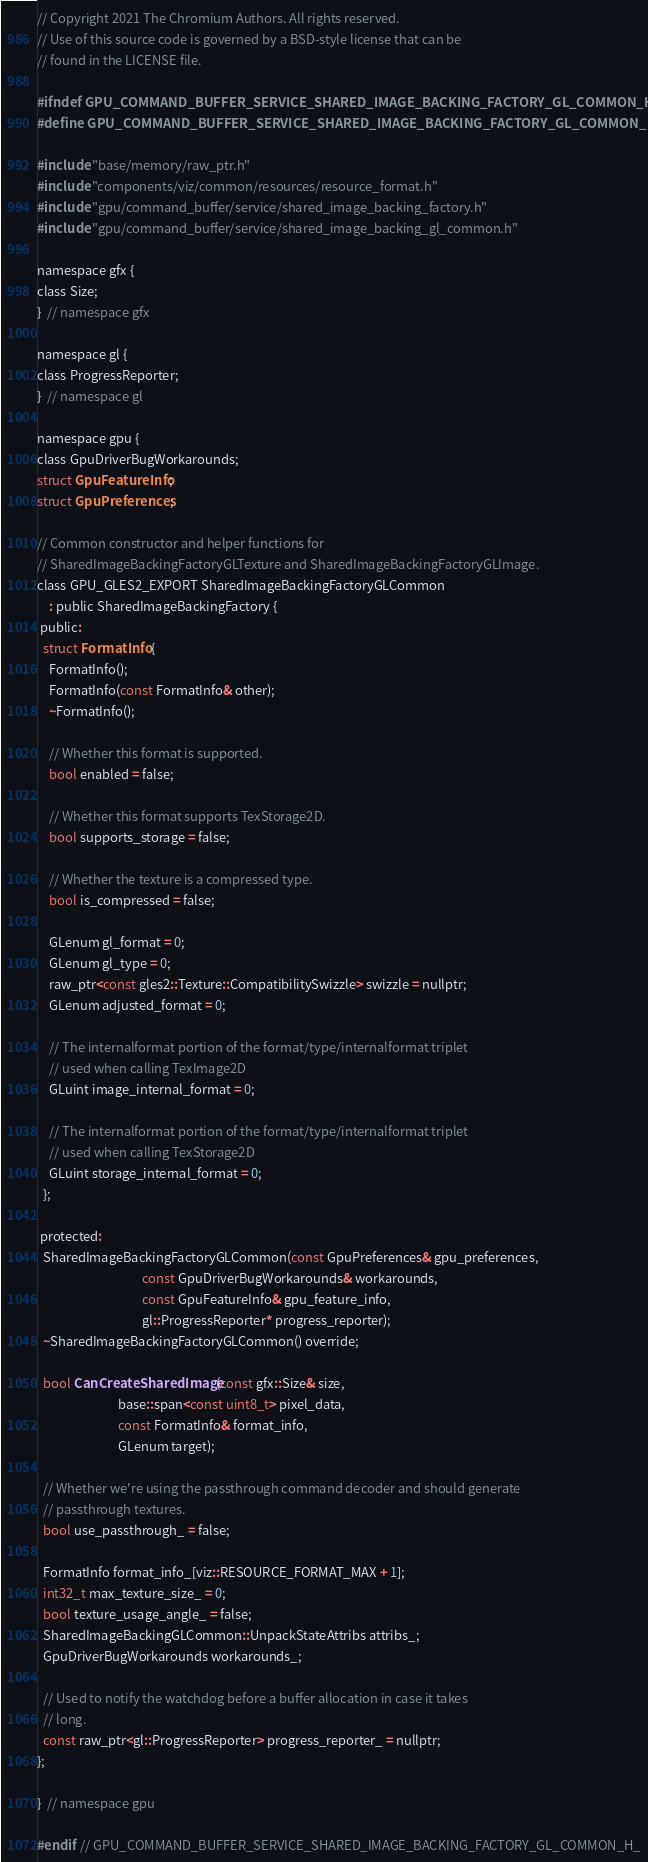<code> <loc_0><loc_0><loc_500><loc_500><_C_>// Copyright 2021 The Chromium Authors. All rights reserved.
// Use of this source code is governed by a BSD-style license that can be
// found in the LICENSE file.

#ifndef GPU_COMMAND_BUFFER_SERVICE_SHARED_IMAGE_BACKING_FACTORY_GL_COMMON_H_
#define GPU_COMMAND_BUFFER_SERVICE_SHARED_IMAGE_BACKING_FACTORY_GL_COMMON_H_

#include "base/memory/raw_ptr.h"
#include "components/viz/common/resources/resource_format.h"
#include "gpu/command_buffer/service/shared_image_backing_factory.h"
#include "gpu/command_buffer/service/shared_image_backing_gl_common.h"

namespace gfx {
class Size;
}  // namespace gfx

namespace gl {
class ProgressReporter;
}  // namespace gl

namespace gpu {
class GpuDriverBugWorkarounds;
struct GpuFeatureInfo;
struct GpuPreferences;

// Common constructor and helper functions for
// SharedImageBackingFactoryGLTexture and SharedImageBackingFactoryGLImage.
class GPU_GLES2_EXPORT SharedImageBackingFactoryGLCommon
    : public SharedImageBackingFactory {
 public:
  struct FormatInfo {
    FormatInfo();
    FormatInfo(const FormatInfo& other);
    ~FormatInfo();

    // Whether this format is supported.
    bool enabled = false;

    // Whether this format supports TexStorage2D.
    bool supports_storage = false;

    // Whether the texture is a compressed type.
    bool is_compressed = false;

    GLenum gl_format = 0;
    GLenum gl_type = 0;
    raw_ptr<const gles2::Texture::CompatibilitySwizzle> swizzle = nullptr;
    GLenum adjusted_format = 0;

    // The internalformat portion of the format/type/internalformat triplet
    // used when calling TexImage2D
    GLuint image_internal_format = 0;

    // The internalformat portion of the format/type/internalformat triplet
    // used when calling TexStorage2D
    GLuint storage_internal_format = 0;
  };

 protected:
  SharedImageBackingFactoryGLCommon(const GpuPreferences& gpu_preferences,
                                    const GpuDriverBugWorkarounds& workarounds,
                                    const GpuFeatureInfo& gpu_feature_info,
                                    gl::ProgressReporter* progress_reporter);
  ~SharedImageBackingFactoryGLCommon() override;

  bool CanCreateSharedImage(const gfx::Size& size,
                            base::span<const uint8_t> pixel_data,
                            const FormatInfo& format_info,
                            GLenum target);

  // Whether we're using the passthrough command decoder and should generate
  // passthrough textures.
  bool use_passthrough_ = false;

  FormatInfo format_info_[viz::RESOURCE_FORMAT_MAX + 1];
  int32_t max_texture_size_ = 0;
  bool texture_usage_angle_ = false;
  SharedImageBackingGLCommon::UnpackStateAttribs attribs_;
  GpuDriverBugWorkarounds workarounds_;

  // Used to notify the watchdog before a buffer allocation in case it takes
  // long.
  const raw_ptr<gl::ProgressReporter> progress_reporter_ = nullptr;
};

}  // namespace gpu

#endif  // GPU_COMMAND_BUFFER_SERVICE_SHARED_IMAGE_BACKING_FACTORY_GL_COMMON_H_
</code> 